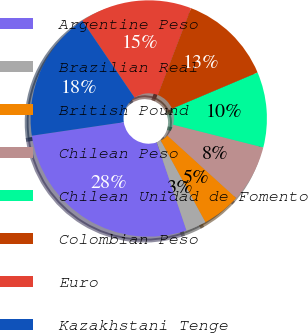Convert chart. <chart><loc_0><loc_0><loc_500><loc_500><pie_chart><fcel>Argentine Peso<fcel>Brazilian Real<fcel>British Pound<fcel>Chilean Peso<fcel>Chilean Unidad de Fomento<fcel>Colombian Peso<fcel>Euro<fcel>Kazakhstani Tenge<nl><fcel>27.86%<fcel>2.79%<fcel>5.29%<fcel>7.8%<fcel>10.31%<fcel>12.81%<fcel>15.32%<fcel>17.83%<nl></chart> 